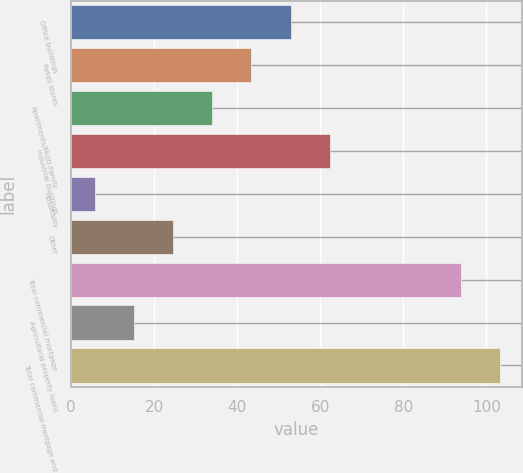Convert chart. <chart><loc_0><loc_0><loc_500><loc_500><bar_chart><fcel>Office buildings<fcel>Retail stores<fcel>Apartments/Multi-Family<fcel>Industrial buildings<fcel>Hospitality<fcel>Other<fcel>Total commercial mortgage<fcel>Agricultural property loans<fcel>Total commercial mortgage and<nl><fcel>52.85<fcel>43.42<fcel>33.99<fcel>62.28<fcel>5.7<fcel>24.56<fcel>93.9<fcel>15.13<fcel>103.33<nl></chart> 